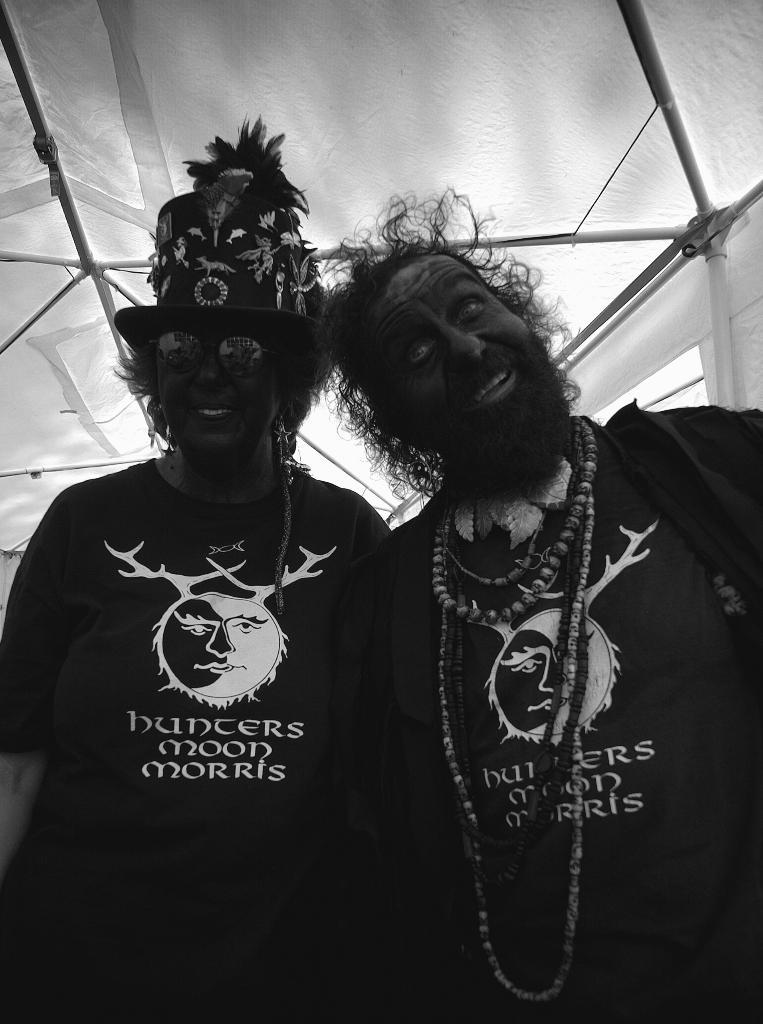How many people are present in the image? There are two people, a man and a woman, present in the image. What is the woman wearing on her head? The woman is wearing a cap in the image. What is the woman wearing over her eyes? The woman is wearing goggles in the image. What expression does the woman have? The woman is smiling in the image. What can be seen in the background of the image? There are rods visible in the background of the image. What type of wall can be seen in the image? There is no wall present in the image. What is the woman holding over her head to protect herself from the rain? The woman is not holding an umbrella or any other object to protect herself from the rain in the image. 